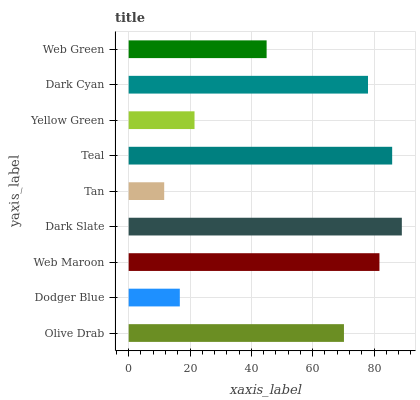Is Tan the minimum?
Answer yes or no. Yes. Is Dark Slate the maximum?
Answer yes or no. Yes. Is Dodger Blue the minimum?
Answer yes or no. No. Is Dodger Blue the maximum?
Answer yes or no. No. Is Olive Drab greater than Dodger Blue?
Answer yes or no. Yes. Is Dodger Blue less than Olive Drab?
Answer yes or no. Yes. Is Dodger Blue greater than Olive Drab?
Answer yes or no. No. Is Olive Drab less than Dodger Blue?
Answer yes or no. No. Is Olive Drab the high median?
Answer yes or no. Yes. Is Olive Drab the low median?
Answer yes or no. Yes. Is Web Maroon the high median?
Answer yes or no. No. Is Yellow Green the low median?
Answer yes or no. No. 